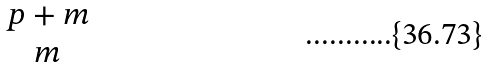Convert formula to latex. <formula><loc_0><loc_0><loc_500><loc_500>\begin{matrix} p + m \\ m \end{matrix}</formula> 